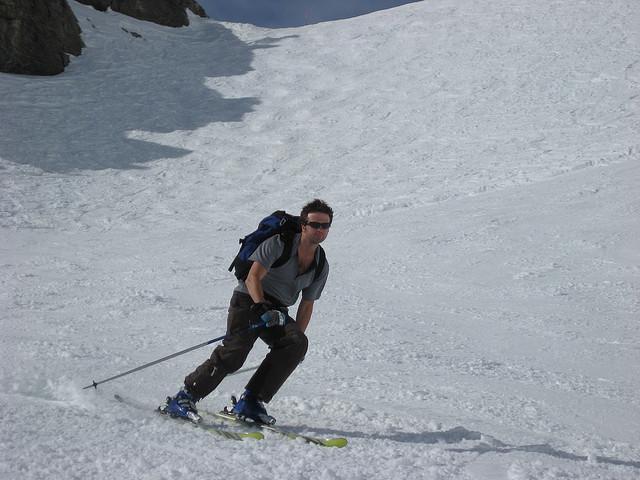What protective gear should the man wear?
Pick the right solution, then justify: 'Answer: answer
Rationale: rationale.'
Options: Headband, scarf, helmet, knee pads. Answer: helmet.
Rationale: He should have something on his head in case he falls. 